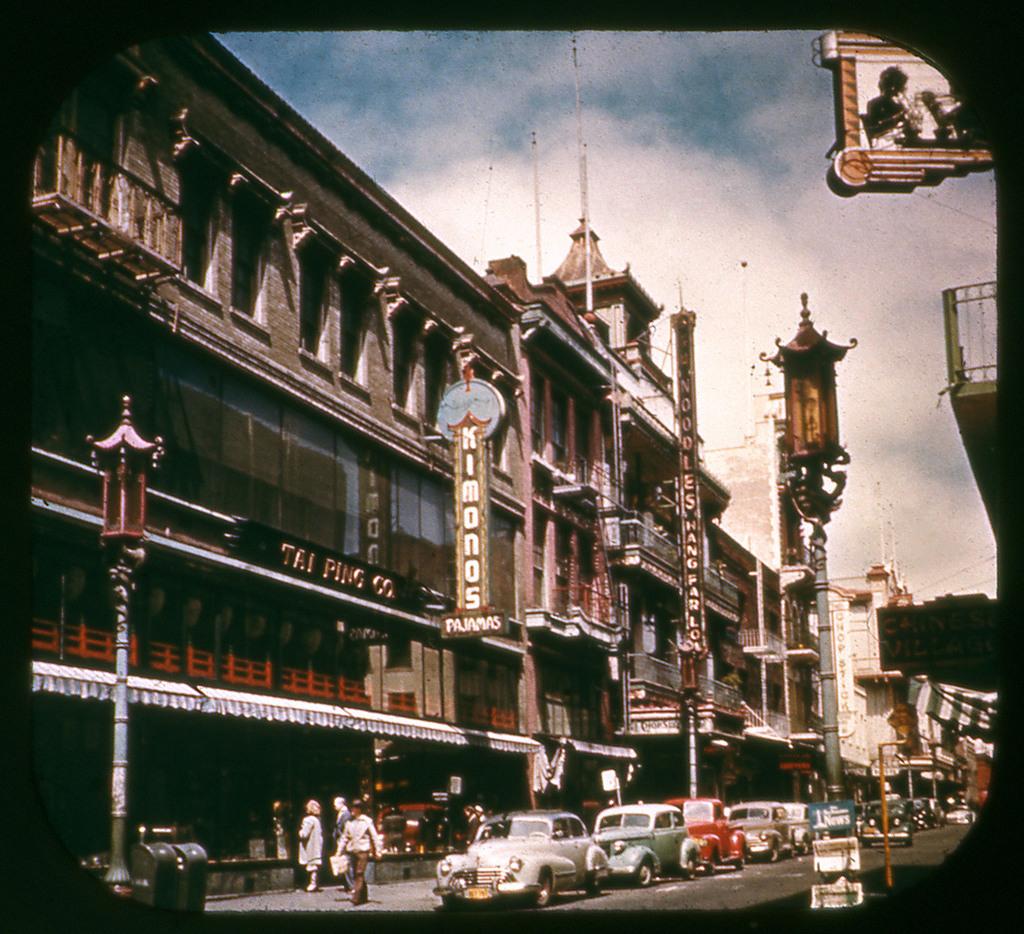What is the name on that building?
Provide a short and direct response. Kimonos. What kind of pajamas?
Your answer should be very brief. Unanswerable. 